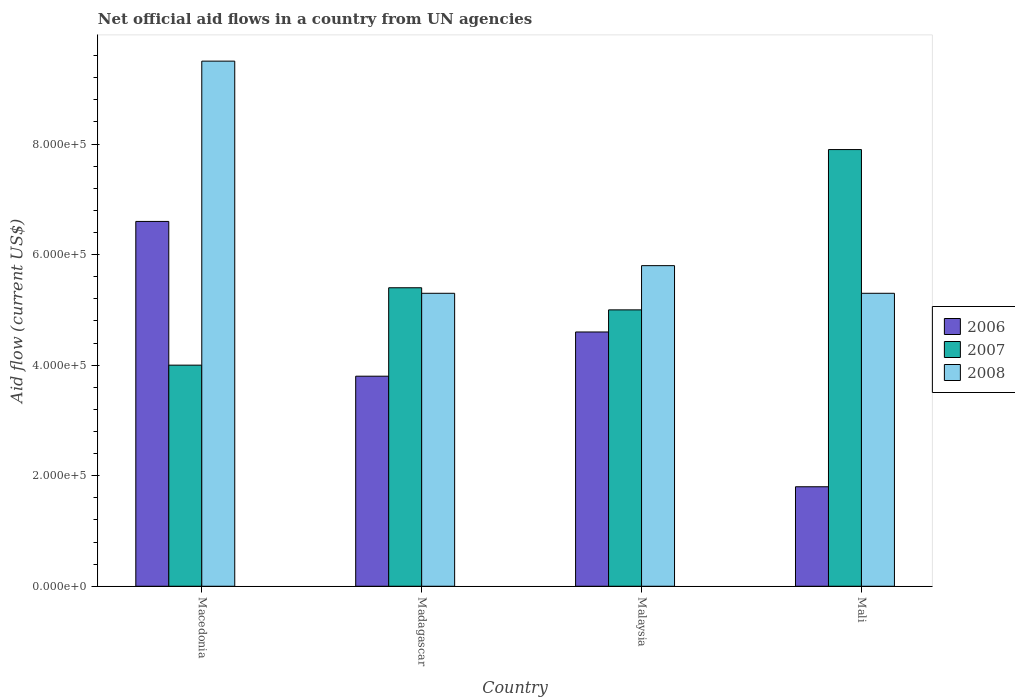How many different coloured bars are there?
Give a very brief answer. 3. Are the number of bars per tick equal to the number of legend labels?
Your answer should be very brief. Yes. Are the number of bars on each tick of the X-axis equal?
Make the answer very short. Yes. How many bars are there on the 4th tick from the left?
Provide a succinct answer. 3. What is the label of the 2nd group of bars from the left?
Provide a succinct answer. Madagascar. Across all countries, what is the maximum net official aid flow in 2008?
Your answer should be very brief. 9.50e+05. Across all countries, what is the minimum net official aid flow in 2008?
Offer a terse response. 5.30e+05. In which country was the net official aid flow in 2006 maximum?
Your answer should be very brief. Macedonia. In which country was the net official aid flow in 2008 minimum?
Keep it short and to the point. Madagascar. What is the total net official aid flow in 2008 in the graph?
Give a very brief answer. 2.59e+06. What is the difference between the net official aid flow in 2007 in Macedonia and that in Madagascar?
Keep it short and to the point. -1.40e+05. What is the difference between the net official aid flow in 2006 in Madagascar and the net official aid flow in 2008 in Macedonia?
Make the answer very short. -5.70e+05. What is the average net official aid flow in 2008 per country?
Make the answer very short. 6.48e+05. In how many countries, is the net official aid flow in 2007 greater than 120000 US$?
Offer a terse response. 4. What is the ratio of the net official aid flow in 2006 in Madagascar to that in Mali?
Provide a short and direct response. 2.11. In how many countries, is the net official aid flow in 2008 greater than the average net official aid flow in 2008 taken over all countries?
Make the answer very short. 1. What does the 1st bar from the left in Madagascar represents?
Offer a very short reply. 2006. What does the 3rd bar from the right in Macedonia represents?
Ensure brevity in your answer.  2006. Is it the case that in every country, the sum of the net official aid flow in 2006 and net official aid flow in 2008 is greater than the net official aid flow in 2007?
Give a very brief answer. No. How many bars are there?
Provide a short and direct response. 12. Are the values on the major ticks of Y-axis written in scientific E-notation?
Ensure brevity in your answer.  Yes. Where does the legend appear in the graph?
Your response must be concise. Center right. How many legend labels are there?
Your answer should be compact. 3. What is the title of the graph?
Your answer should be very brief. Net official aid flows in a country from UN agencies. What is the label or title of the X-axis?
Your response must be concise. Country. What is the label or title of the Y-axis?
Your answer should be very brief. Aid flow (current US$). What is the Aid flow (current US$) of 2008 in Macedonia?
Make the answer very short. 9.50e+05. What is the Aid flow (current US$) in 2006 in Madagascar?
Keep it short and to the point. 3.80e+05. What is the Aid flow (current US$) of 2007 in Madagascar?
Offer a very short reply. 5.40e+05. What is the Aid flow (current US$) of 2008 in Madagascar?
Ensure brevity in your answer.  5.30e+05. What is the Aid flow (current US$) of 2007 in Malaysia?
Offer a very short reply. 5.00e+05. What is the Aid flow (current US$) of 2008 in Malaysia?
Offer a terse response. 5.80e+05. What is the Aid flow (current US$) in 2007 in Mali?
Provide a succinct answer. 7.90e+05. What is the Aid flow (current US$) in 2008 in Mali?
Give a very brief answer. 5.30e+05. Across all countries, what is the maximum Aid flow (current US$) of 2006?
Your response must be concise. 6.60e+05. Across all countries, what is the maximum Aid flow (current US$) of 2007?
Ensure brevity in your answer.  7.90e+05. Across all countries, what is the maximum Aid flow (current US$) in 2008?
Your answer should be compact. 9.50e+05. Across all countries, what is the minimum Aid flow (current US$) of 2006?
Provide a succinct answer. 1.80e+05. Across all countries, what is the minimum Aid flow (current US$) in 2008?
Offer a terse response. 5.30e+05. What is the total Aid flow (current US$) of 2006 in the graph?
Offer a terse response. 1.68e+06. What is the total Aid flow (current US$) in 2007 in the graph?
Provide a short and direct response. 2.23e+06. What is the total Aid flow (current US$) in 2008 in the graph?
Your answer should be very brief. 2.59e+06. What is the difference between the Aid flow (current US$) of 2007 in Macedonia and that in Madagascar?
Your answer should be very brief. -1.40e+05. What is the difference between the Aid flow (current US$) in 2006 in Macedonia and that in Malaysia?
Give a very brief answer. 2.00e+05. What is the difference between the Aid flow (current US$) of 2007 in Macedonia and that in Malaysia?
Your answer should be very brief. -1.00e+05. What is the difference between the Aid flow (current US$) in 2007 in Macedonia and that in Mali?
Keep it short and to the point. -3.90e+05. What is the difference between the Aid flow (current US$) in 2008 in Macedonia and that in Mali?
Provide a succinct answer. 4.20e+05. What is the difference between the Aid flow (current US$) in 2007 in Madagascar and that in Malaysia?
Make the answer very short. 4.00e+04. What is the difference between the Aid flow (current US$) in 2007 in Madagascar and that in Mali?
Give a very brief answer. -2.50e+05. What is the difference between the Aid flow (current US$) of 2008 in Madagascar and that in Mali?
Ensure brevity in your answer.  0. What is the difference between the Aid flow (current US$) of 2006 in Malaysia and that in Mali?
Your answer should be very brief. 2.80e+05. What is the difference between the Aid flow (current US$) in 2008 in Malaysia and that in Mali?
Give a very brief answer. 5.00e+04. What is the difference between the Aid flow (current US$) of 2006 in Macedonia and the Aid flow (current US$) of 2007 in Madagascar?
Give a very brief answer. 1.20e+05. What is the difference between the Aid flow (current US$) of 2006 in Macedonia and the Aid flow (current US$) of 2008 in Madagascar?
Make the answer very short. 1.30e+05. What is the difference between the Aid flow (current US$) of 2007 in Macedonia and the Aid flow (current US$) of 2008 in Madagascar?
Offer a very short reply. -1.30e+05. What is the difference between the Aid flow (current US$) in 2006 in Macedonia and the Aid flow (current US$) in 2007 in Mali?
Give a very brief answer. -1.30e+05. What is the difference between the Aid flow (current US$) in 2006 in Madagascar and the Aid flow (current US$) in 2007 in Malaysia?
Your answer should be very brief. -1.20e+05. What is the difference between the Aid flow (current US$) in 2006 in Madagascar and the Aid flow (current US$) in 2008 in Malaysia?
Offer a very short reply. -2.00e+05. What is the difference between the Aid flow (current US$) in 2007 in Madagascar and the Aid flow (current US$) in 2008 in Malaysia?
Your answer should be compact. -4.00e+04. What is the difference between the Aid flow (current US$) of 2006 in Madagascar and the Aid flow (current US$) of 2007 in Mali?
Offer a very short reply. -4.10e+05. What is the difference between the Aid flow (current US$) in 2006 in Madagascar and the Aid flow (current US$) in 2008 in Mali?
Your answer should be very brief. -1.50e+05. What is the difference between the Aid flow (current US$) in 2006 in Malaysia and the Aid flow (current US$) in 2007 in Mali?
Offer a terse response. -3.30e+05. What is the difference between the Aid flow (current US$) of 2007 in Malaysia and the Aid flow (current US$) of 2008 in Mali?
Your answer should be compact. -3.00e+04. What is the average Aid flow (current US$) of 2006 per country?
Offer a terse response. 4.20e+05. What is the average Aid flow (current US$) in 2007 per country?
Provide a succinct answer. 5.58e+05. What is the average Aid flow (current US$) of 2008 per country?
Your answer should be very brief. 6.48e+05. What is the difference between the Aid flow (current US$) of 2006 and Aid flow (current US$) of 2007 in Macedonia?
Give a very brief answer. 2.60e+05. What is the difference between the Aid flow (current US$) in 2007 and Aid flow (current US$) in 2008 in Macedonia?
Give a very brief answer. -5.50e+05. What is the difference between the Aid flow (current US$) in 2006 and Aid flow (current US$) in 2007 in Madagascar?
Your answer should be very brief. -1.60e+05. What is the difference between the Aid flow (current US$) of 2006 and Aid flow (current US$) of 2008 in Madagascar?
Provide a short and direct response. -1.50e+05. What is the difference between the Aid flow (current US$) of 2007 and Aid flow (current US$) of 2008 in Madagascar?
Give a very brief answer. 10000. What is the difference between the Aid flow (current US$) in 2006 and Aid flow (current US$) in 2007 in Malaysia?
Ensure brevity in your answer.  -4.00e+04. What is the difference between the Aid flow (current US$) of 2007 and Aid flow (current US$) of 2008 in Malaysia?
Your answer should be compact. -8.00e+04. What is the difference between the Aid flow (current US$) in 2006 and Aid flow (current US$) in 2007 in Mali?
Your answer should be compact. -6.10e+05. What is the difference between the Aid flow (current US$) in 2006 and Aid flow (current US$) in 2008 in Mali?
Provide a succinct answer. -3.50e+05. What is the difference between the Aid flow (current US$) of 2007 and Aid flow (current US$) of 2008 in Mali?
Your answer should be compact. 2.60e+05. What is the ratio of the Aid flow (current US$) in 2006 in Macedonia to that in Madagascar?
Give a very brief answer. 1.74. What is the ratio of the Aid flow (current US$) in 2007 in Macedonia to that in Madagascar?
Make the answer very short. 0.74. What is the ratio of the Aid flow (current US$) of 2008 in Macedonia to that in Madagascar?
Ensure brevity in your answer.  1.79. What is the ratio of the Aid flow (current US$) in 2006 in Macedonia to that in Malaysia?
Provide a short and direct response. 1.43. What is the ratio of the Aid flow (current US$) in 2008 in Macedonia to that in Malaysia?
Your response must be concise. 1.64. What is the ratio of the Aid flow (current US$) in 2006 in Macedonia to that in Mali?
Offer a terse response. 3.67. What is the ratio of the Aid flow (current US$) of 2007 in Macedonia to that in Mali?
Ensure brevity in your answer.  0.51. What is the ratio of the Aid flow (current US$) in 2008 in Macedonia to that in Mali?
Your answer should be very brief. 1.79. What is the ratio of the Aid flow (current US$) of 2006 in Madagascar to that in Malaysia?
Provide a succinct answer. 0.83. What is the ratio of the Aid flow (current US$) in 2008 in Madagascar to that in Malaysia?
Ensure brevity in your answer.  0.91. What is the ratio of the Aid flow (current US$) of 2006 in Madagascar to that in Mali?
Offer a very short reply. 2.11. What is the ratio of the Aid flow (current US$) of 2007 in Madagascar to that in Mali?
Ensure brevity in your answer.  0.68. What is the ratio of the Aid flow (current US$) of 2008 in Madagascar to that in Mali?
Provide a succinct answer. 1. What is the ratio of the Aid flow (current US$) of 2006 in Malaysia to that in Mali?
Your response must be concise. 2.56. What is the ratio of the Aid flow (current US$) of 2007 in Malaysia to that in Mali?
Your response must be concise. 0.63. What is the ratio of the Aid flow (current US$) in 2008 in Malaysia to that in Mali?
Give a very brief answer. 1.09. What is the difference between the highest and the second highest Aid flow (current US$) of 2006?
Offer a very short reply. 2.00e+05. What is the difference between the highest and the second highest Aid flow (current US$) of 2008?
Offer a terse response. 3.70e+05. What is the difference between the highest and the lowest Aid flow (current US$) in 2008?
Give a very brief answer. 4.20e+05. 